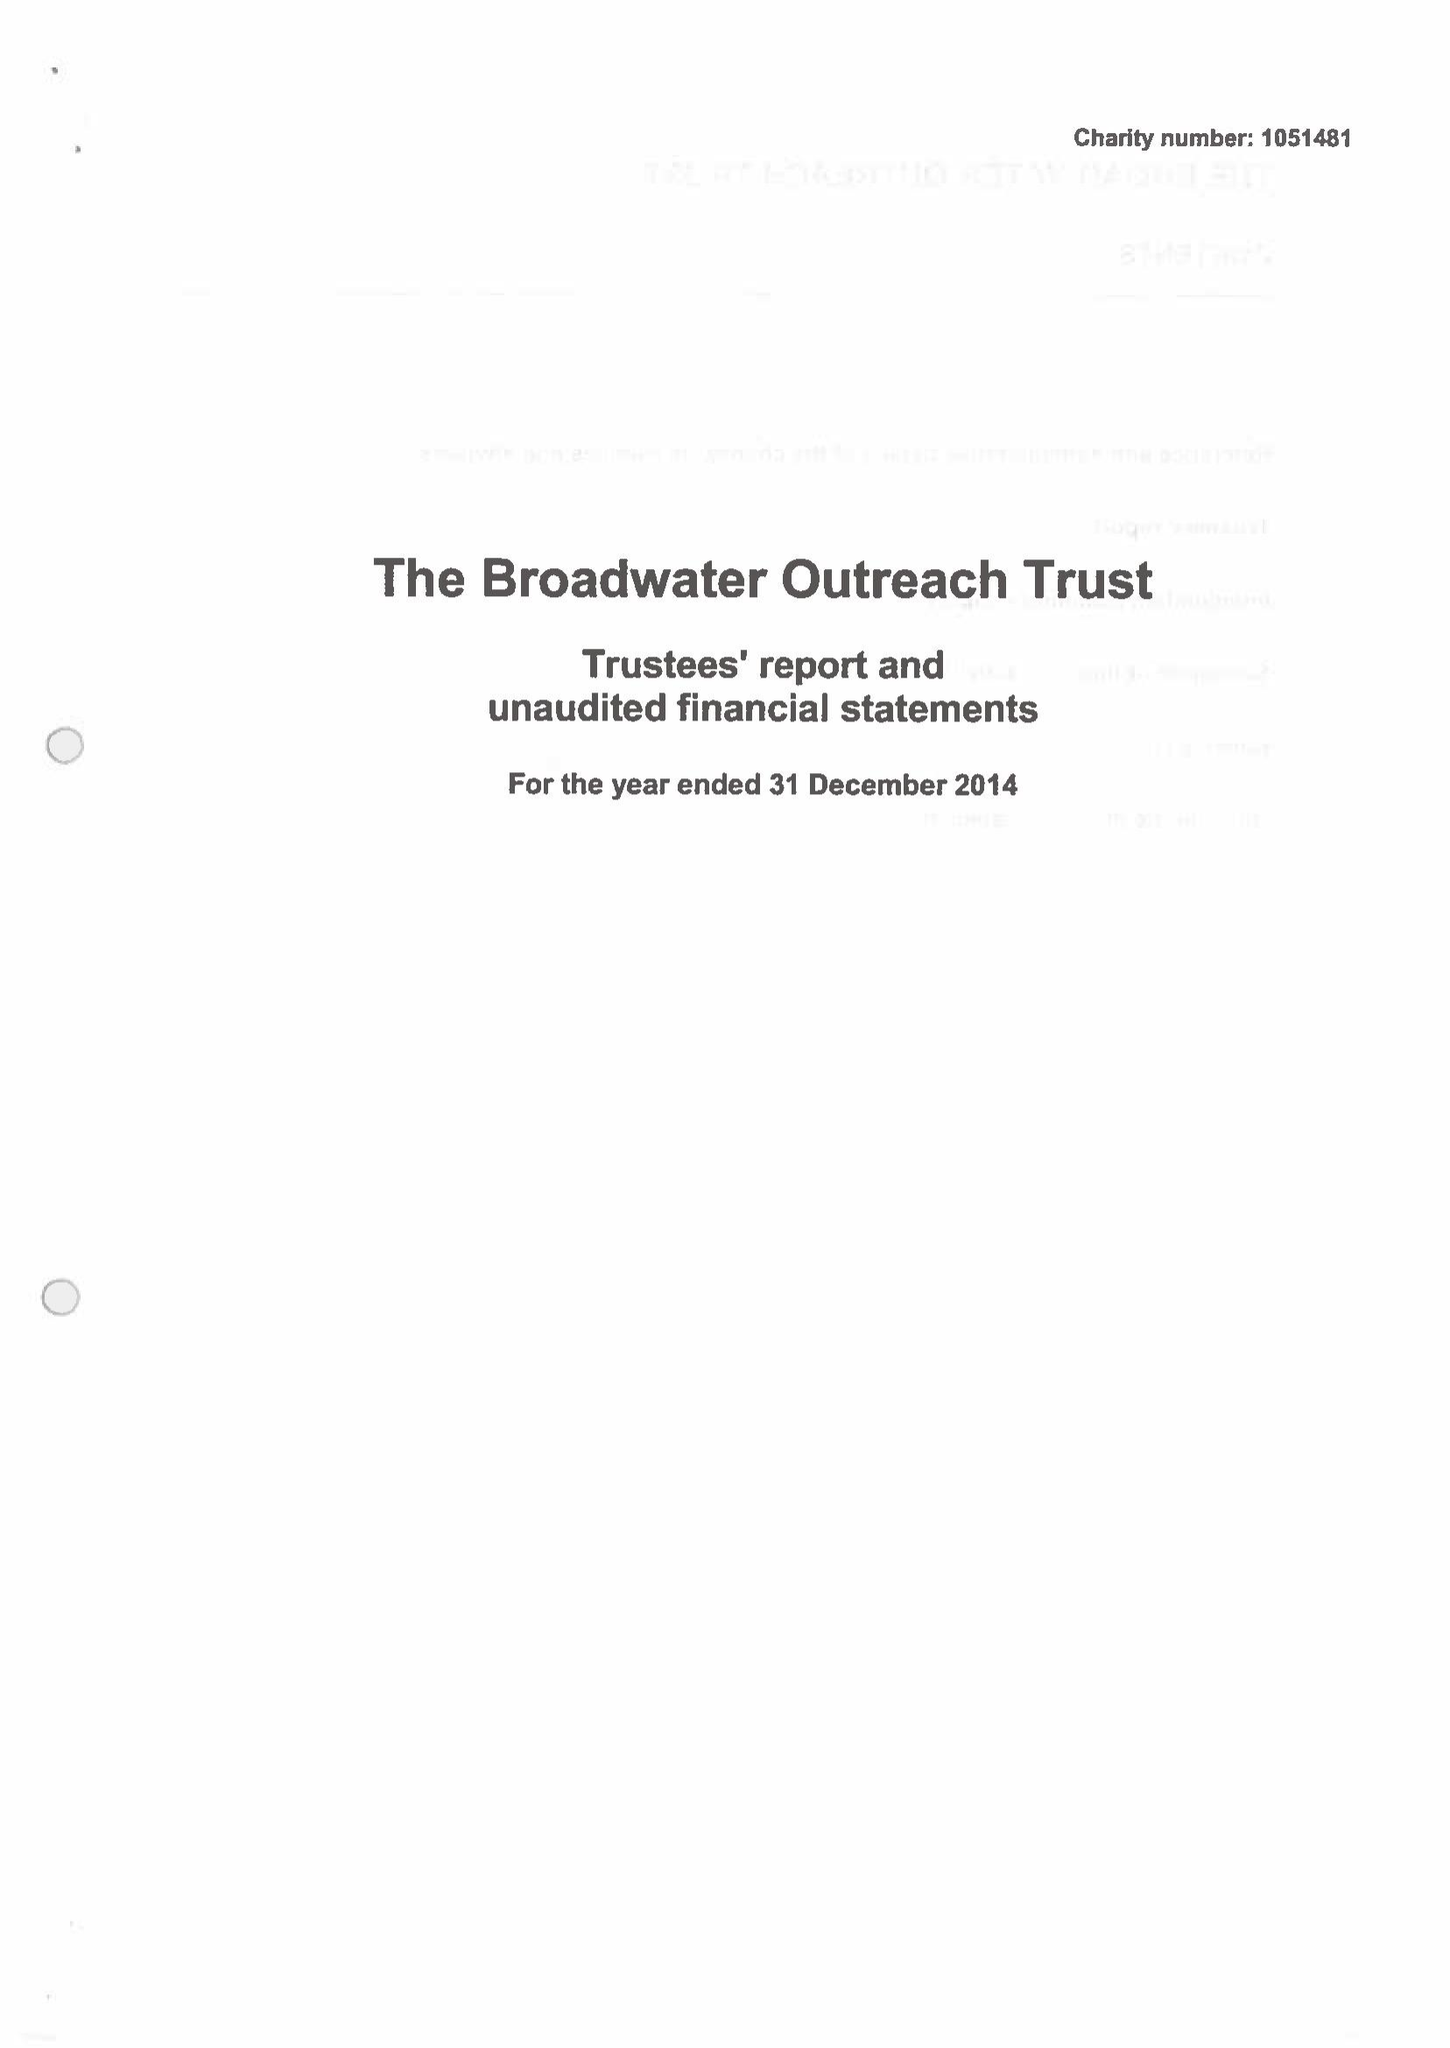What is the value for the charity_number?
Answer the question using a single word or phrase. 1051481 